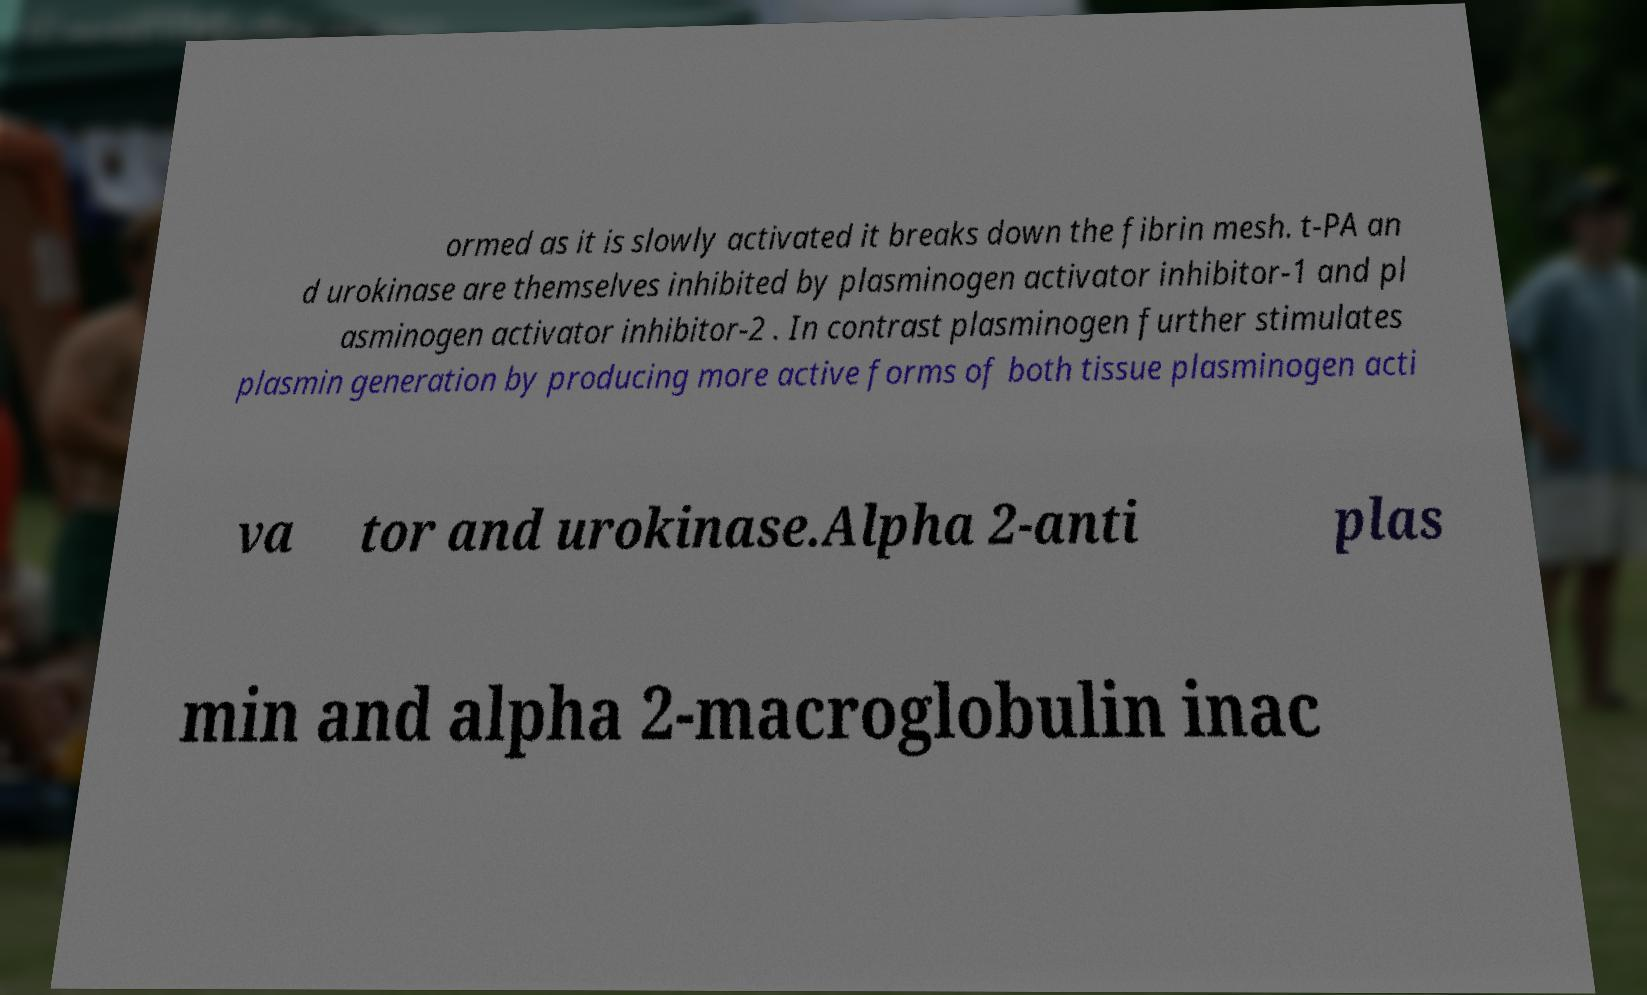Can you read and provide the text displayed in the image?This photo seems to have some interesting text. Can you extract and type it out for me? ormed as it is slowly activated it breaks down the fibrin mesh. t-PA an d urokinase are themselves inhibited by plasminogen activator inhibitor-1 and pl asminogen activator inhibitor-2 . In contrast plasminogen further stimulates plasmin generation by producing more active forms of both tissue plasminogen acti va tor and urokinase.Alpha 2-anti plas min and alpha 2-macroglobulin inac 